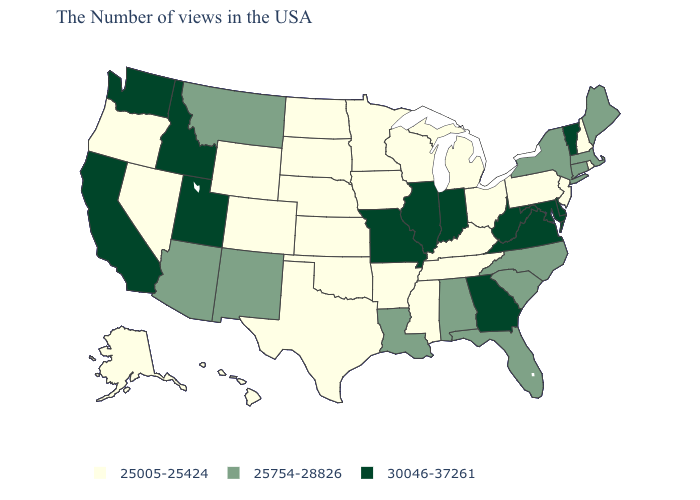What is the lowest value in the USA?
Keep it brief. 25005-25424. Name the states that have a value in the range 25005-25424?
Give a very brief answer. Rhode Island, New Hampshire, New Jersey, Pennsylvania, Ohio, Michigan, Kentucky, Tennessee, Wisconsin, Mississippi, Arkansas, Minnesota, Iowa, Kansas, Nebraska, Oklahoma, Texas, South Dakota, North Dakota, Wyoming, Colorado, Nevada, Oregon, Alaska, Hawaii. What is the lowest value in states that border Nevada?
Write a very short answer. 25005-25424. What is the value of Michigan?
Give a very brief answer. 25005-25424. What is the lowest value in the USA?
Write a very short answer. 25005-25424. Does Mississippi have the highest value in the USA?
Concise answer only. No. Does the map have missing data?
Keep it brief. No. Which states have the lowest value in the West?
Be succinct. Wyoming, Colorado, Nevada, Oregon, Alaska, Hawaii. Does the map have missing data?
Be succinct. No. Name the states that have a value in the range 25754-28826?
Short answer required. Maine, Massachusetts, Connecticut, New York, North Carolina, South Carolina, Florida, Alabama, Louisiana, New Mexico, Montana, Arizona. What is the lowest value in the West?
Write a very short answer. 25005-25424. What is the value of Wisconsin?
Give a very brief answer. 25005-25424. What is the lowest value in the South?
Short answer required. 25005-25424. Name the states that have a value in the range 25005-25424?
Be succinct. Rhode Island, New Hampshire, New Jersey, Pennsylvania, Ohio, Michigan, Kentucky, Tennessee, Wisconsin, Mississippi, Arkansas, Minnesota, Iowa, Kansas, Nebraska, Oklahoma, Texas, South Dakota, North Dakota, Wyoming, Colorado, Nevada, Oregon, Alaska, Hawaii. 